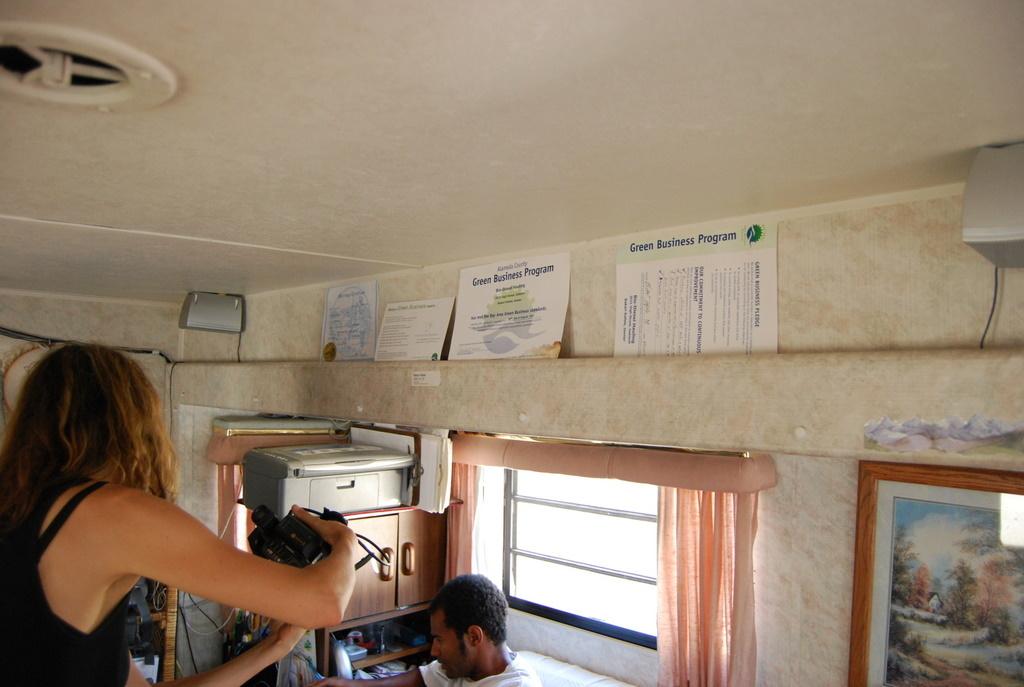What sort of business program does the paper say?
Keep it short and to the point. Green. Are those certificate's from school's on the top row?
Your answer should be very brief. Yes. 